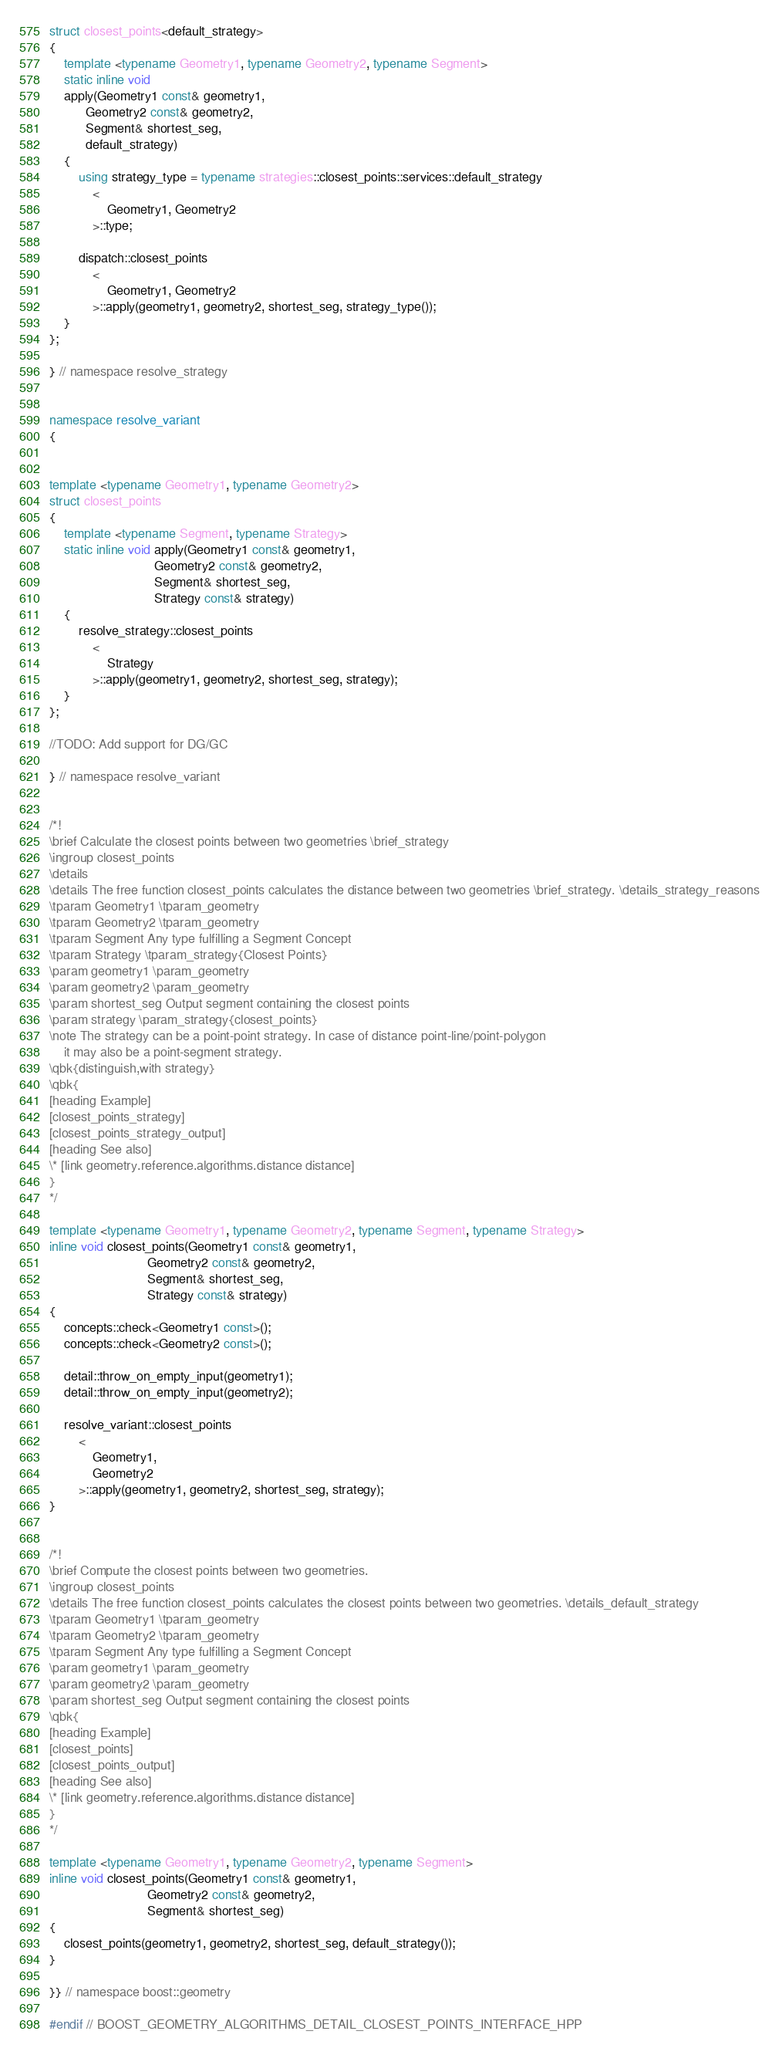Convert code to text. <code><loc_0><loc_0><loc_500><loc_500><_C++_>struct closest_points<default_strategy>
{
    template <typename Geometry1, typename Geometry2, typename Segment>
    static inline void
    apply(Geometry1 const& geometry1,
          Geometry2 const& geometry2,
          Segment& shortest_seg,
          default_strategy)
    {
        using strategy_type = typename strategies::closest_points::services::default_strategy
            <
                Geometry1, Geometry2
            >::type;

        dispatch::closest_points
            <
                Geometry1, Geometry2
            >::apply(geometry1, geometry2, shortest_seg, strategy_type());
    }
};

} // namespace resolve_strategy


namespace resolve_variant
{


template <typename Geometry1, typename Geometry2>
struct closest_points
{
    template <typename Segment, typename Strategy>
    static inline void apply(Geometry1 const& geometry1,
                             Geometry2 const& geometry2,
                             Segment& shortest_seg,
                             Strategy const& strategy)
    {
        resolve_strategy::closest_points
            <
                Strategy
            >::apply(geometry1, geometry2, shortest_seg, strategy);
    }
};

//TODO: Add support for DG/GC

} // namespace resolve_variant


/*!
\brief Calculate the closest points between two geometries \brief_strategy
\ingroup closest_points
\details
\details The free function closest_points calculates the distance between two geometries \brief_strategy. \details_strategy_reasons
\tparam Geometry1 \tparam_geometry
\tparam Geometry2 \tparam_geometry
\tparam Segment Any type fulfilling a Segment Concept
\tparam Strategy \tparam_strategy{Closest Points}
\param geometry1 \param_geometry
\param geometry2 \param_geometry
\param shortest_seg Output segment containing the closest points
\param strategy \param_strategy{closest_points}
\note The strategy can be a point-point strategy. In case of distance point-line/point-polygon
    it may also be a point-segment strategy.
\qbk{distinguish,with strategy}
\qbk{
[heading Example]
[closest_points_strategy]
[closest_points_strategy_output]
[heading See also]
\* [link geometry.reference.algorithms.distance distance]
}
*/

template <typename Geometry1, typename Geometry2, typename Segment, typename Strategy>
inline void closest_points(Geometry1 const& geometry1,
                           Geometry2 const& geometry2,
                           Segment& shortest_seg,
                           Strategy const& strategy)
{
    concepts::check<Geometry1 const>();
    concepts::check<Geometry2 const>();

    detail::throw_on_empty_input(geometry1);
    detail::throw_on_empty_input(geometry2);

    resolve_variant::closest_points
        <
            Geometry1,
            Geometry2
        >::apply(geometry1, geometry2, shortest_seg, strategy);
}


/*!
\brief Compute the closest points between two geometries.
\ingroup closest_points
\details The free function closest_points calculates the closest points between two geometries. \details_default_strategy
\tparam Geometry1 \tparam_geometry
\tparam Geometry2 \tparam_geometry
\tparam Segment Any type fulfilling a Segment Concept
\param geometry1 \param_geometry
\param geometry2 \param_geometry
\param shortest_seg Output segment containing the closest points
\qbk{
[heading Example]
[closest_points]
[closest_points_output]
[heading See also]
\* [link geometry.reference.algorithms.distance distance]
}
*/

template <typename Geometry1, typename Geometry2, typename Segment>
inline void closest_points(Geometry1 const& geometry1,
                           Geometry2 const& geometry2,
                           Segment& shortest_seg)
{
    closest_points(geometry1, geometry2, shortest_seg, default_strategy());
}

}} // namespace boost::geometry

#endif // BOOST_GEOMETRY_ALGORITHMS_DETAIL_CLOSEST_POINTS_INTERFACE_HPP
</code> 